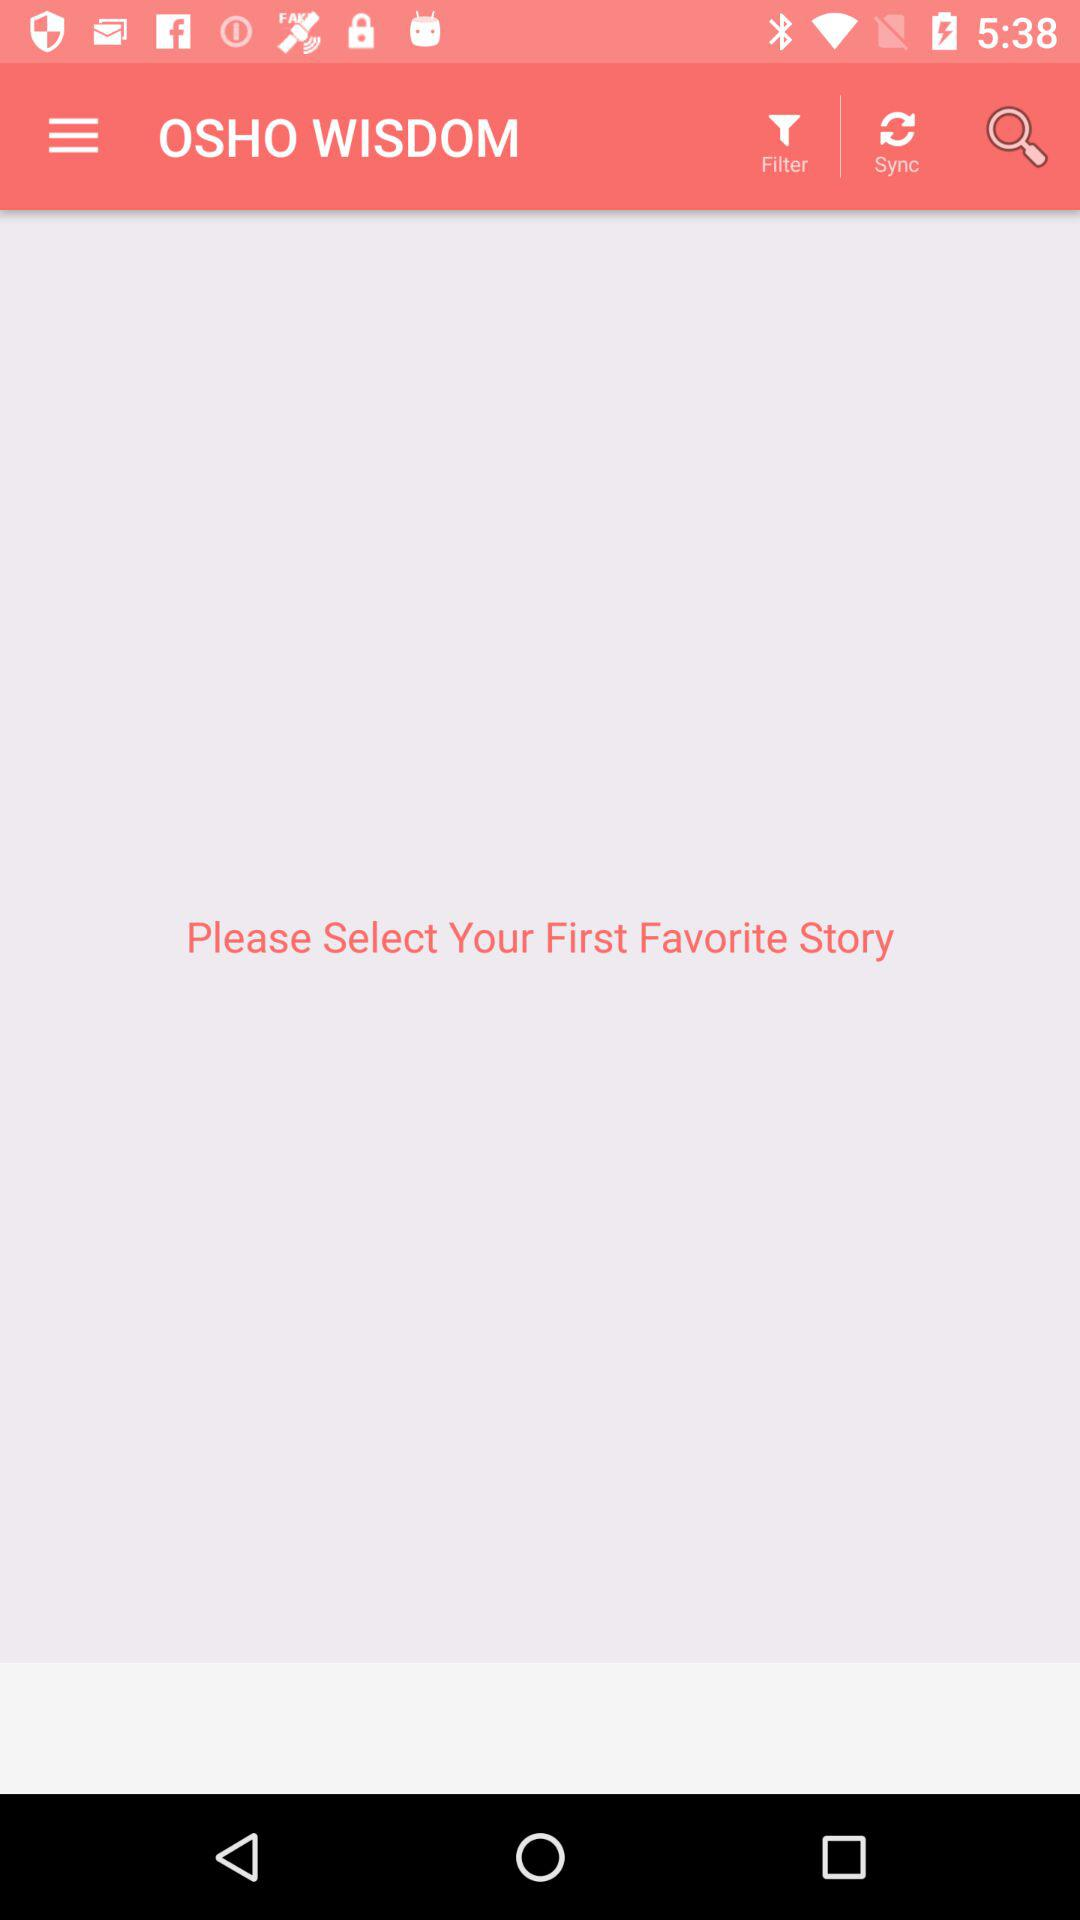What is the application name? The application name is "OSHO WISDOM". 